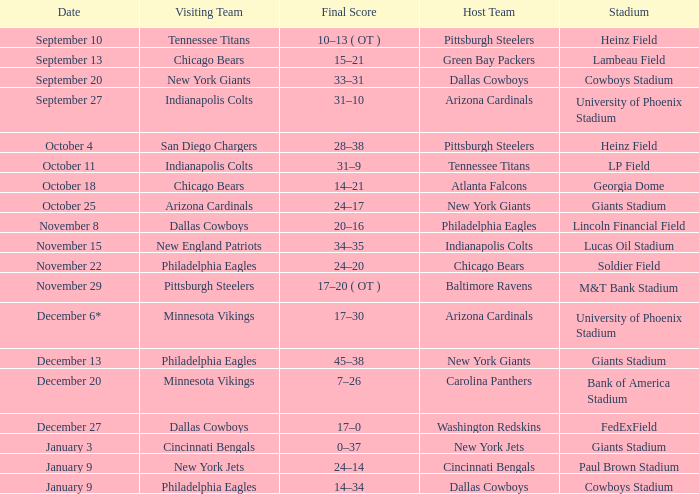Tell me the host team for giants stadium and visiting of cincinnati bengals New York Jets. 